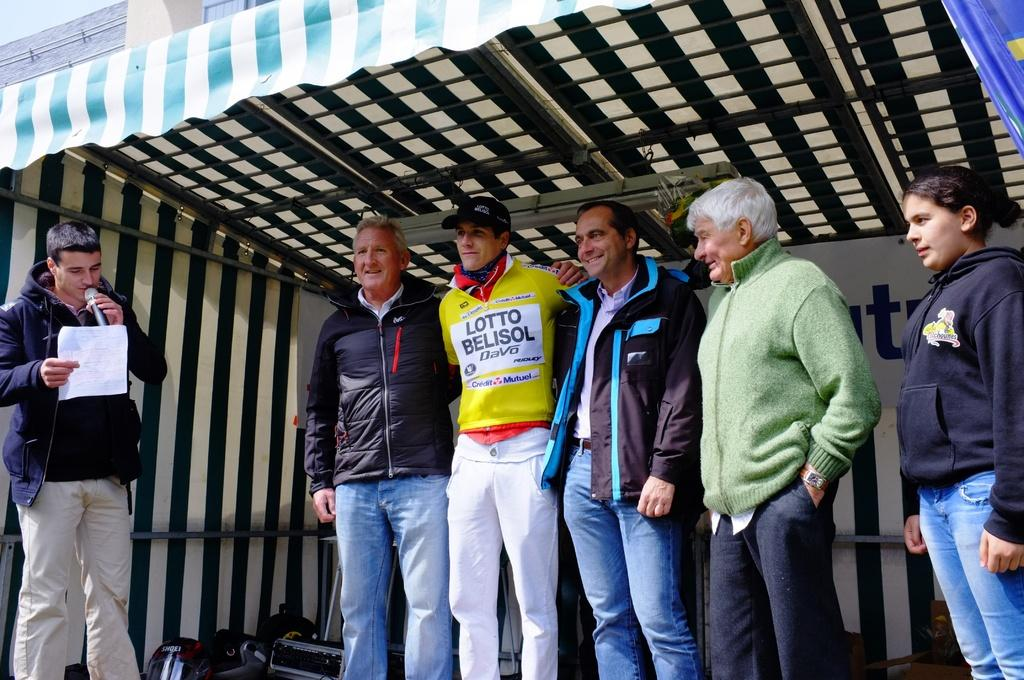<image>
Provide a brief description of the given image. On a stage, people flank a young man in a LOTTO BELISOL uniform. 